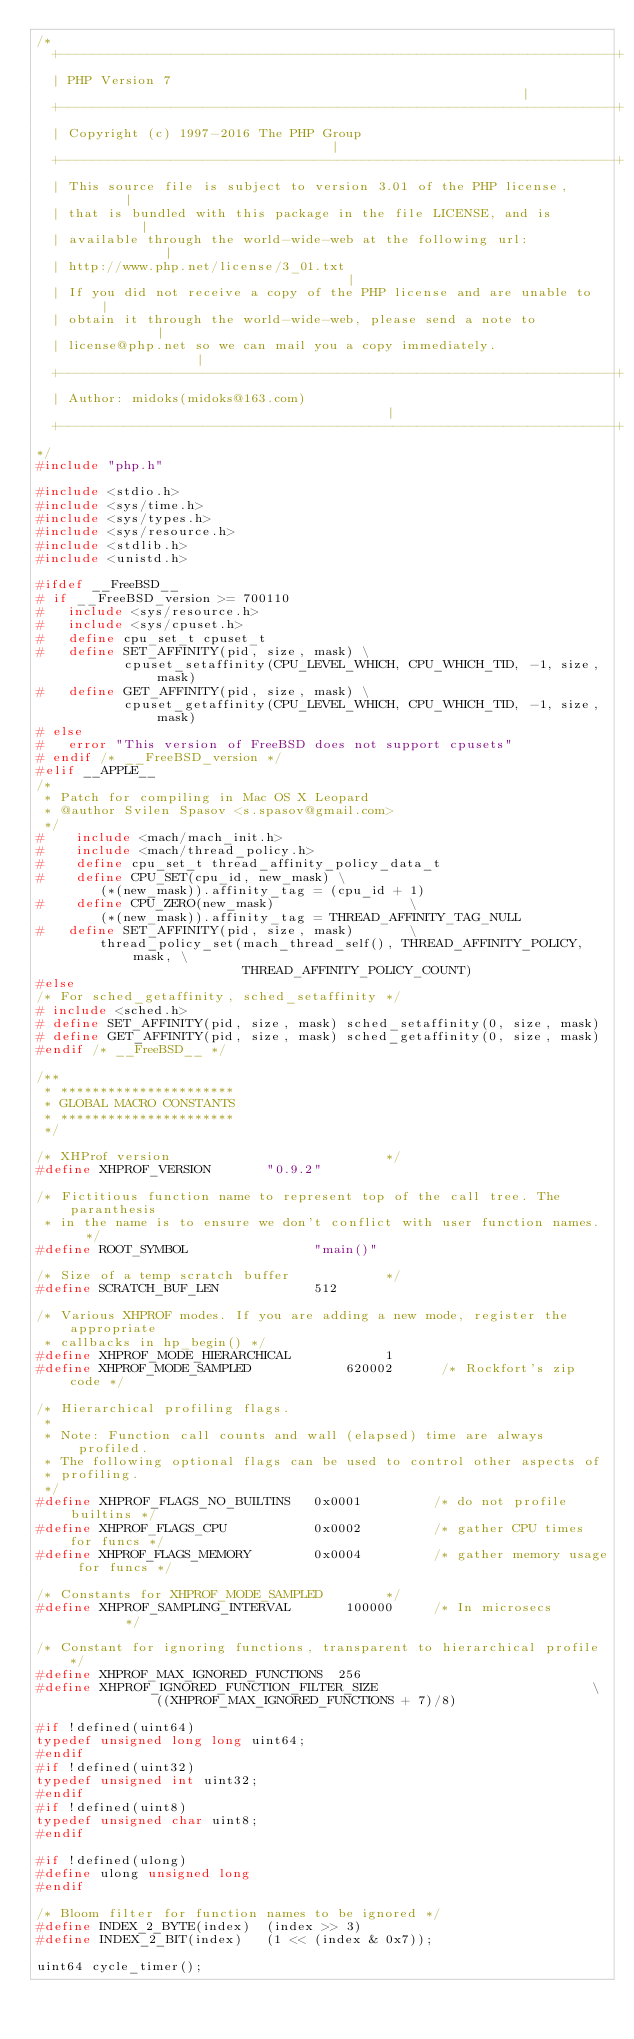<code> <loc_0><loc_0><loc_500><loc_500><_C_>/*
  +----------------------------------------------------------------------+
  | PHP Version 7                                                        |
  +----------------------------------------------------------------------+
  | Copyright (c) 1997-2016 The PHP Group                                |
  +----------------------------------------------------------------------+
  | This source file is subject to version 3.01 of the PHP license,      |
  | that is bundled with this package in the file LICENSE, and is        |
  | available through the world-wide-web at the following url:           |
  | http://www.php.net/license/3_01.txt                                  |
  | If you did not receive a copy of the PHP license and are unable to   |
  | obtain it through the world-wide-web, please send a note to          |
  | license@php.net so we can mail you a copy immediately.               |
  +----------------------------------------------------------------------+
  | Author: midoks(midoks@163.com)                                       |
  +----------------------------------------------------------------------+
*/
#include "php.h"

#include <stdio.h>
#include <sys/time.h>
#include <sys/types.h>
#include <sys/resource.h>
#include <stdlib.h>
#include <unistd.h>

#ifdef __FreeBSD__
# if __FreeBSD_version >= 700110
#   include <sys/resource.h>
#   include <sys/cpuset.h>
#   define cpu_set_t cpuset_t
#   define SET_AFFINITY(pid, size, mask) \
           cpuset_setaffinity(CPU_LEVEL_WHICH, CPU_WHICH_TID, -1, size, mask)
#   define GET_AFFINITY(pid, size, mask) \
           cpuset_getaffinity(CPU_LEVEL_WHICH, CPU_WHICH_TID, -1, size, mask)
# else
#   error "This version of FreeBSD does not support cpusets"
# endif /* __FreeBSD_version */
#elif __APPLE__
/*
 * Patch for compiling in Mac OS X Leopard
 * @author Svilen Spasov <s.spasov@gmail.com>
 */
#    include <mach/mach_init.h>
#    include <mach/thread_policy.h>
#    define cpu_set_t thread_affinity_policy_data_t
#    define CPU_SET(cpu_id, new_mask) \
        (*(new_mask)).affinity_tag = (cpu_id + 1)
#    define CPU_ZERO(new_mask)                 \
        (*(new_mask)).affinity_tag = THREAD_AFFINITY_TAG_NULL
#   define SET_AFFINITY(pid, size, mask)       \
        thread_policy_set(mach_thread_self(), THREAD_AFFINITY_POLICY, mask, \
                          THREAD_AFFINITY_POLICY_COUNT)
#else
/* For sched_getaffinity, sched_setaffinity */
# include <sched.h>
# define SET_AFFINITY(pid, size, mask) sched_setaffinity(0, size, mask)
# define GET_AFFINITY(pid, size, mask) sched_getaffinity(0, size, mask)
#endif /* __FreeBSD__ */

/**
 * **********************
 * GLOBAL MACRO CONSTANTS
 * **********************
 */

/* XHProf version                           */
#define XHPROF_VERSION       "0.9.2"

/* Fictitious function name to represent top of the call tree. The paranthesis
 * in the name is to ensure we don't conflict with user function names.  */
#define ROOT_SYMBOL                "main()"

/* Size of a temp scratch buffer            */
#define SCRATCH_BUF_LEN            512

/* Various XHPROF modes. If you are adding a new mode, register the appropriate
 * callbacks in hp_begin() */
#define XHPROF_MODE_HIERARCHICAL            1
#define XHPROF_MODE_SAMPLED            620002      /* Rockfort's zip code */

/* Hierarchical profiling flags.
 *
 * Note: Function call counts and wall (elapsed) time are always profiled.
 * The following optional flags can be used to control other aspects of
 * profiling.
 */
#define XHPROF_FLAGS_NO_BUILTINS   0x0001         /* do not profile builtins */
#define XHPROF_FLAGS_CPU           0x0002         /* gather CPU times for funcs */
#define XHPROF_FLAGS_MEMORY        0x0004         /* gather memory usage for funcs */

/* Constants for XHPROF_MODE_SAMPLED        */
#define XHPROF_SAMPLING_INTERVAL       100000     /* In microsecs        */

/* Constant for ignoring functions, transparent to hierarchical profile */
#define XHPROF_MAX_IGNORED_FUNCTIONS  256
#define XHPROF_IGNORED_FUNCTION_FILTER_SIZE                           \
               ((XHPROF_MAX_IGNORED_FUNCTIONS + 7)/8)

#if !defined(uint64)
typedef unsigned long long uint64;
#endif
#if !defined(uint32)
typedef unsigned int uint32;
#endif
#if !defined(uint8)
typedef unsigned char uint8;
#endif

#if !defined(ulong)
#define ulong unsigned long
#endif

/* Bloom filter for function names to be ignored */
#define INDEX_2_BYTE(index)  (index >> 3)
#define INDEX_2_BIT(index)   (1 << (index & 0x7));

uint64 cycle_timer();</code> 